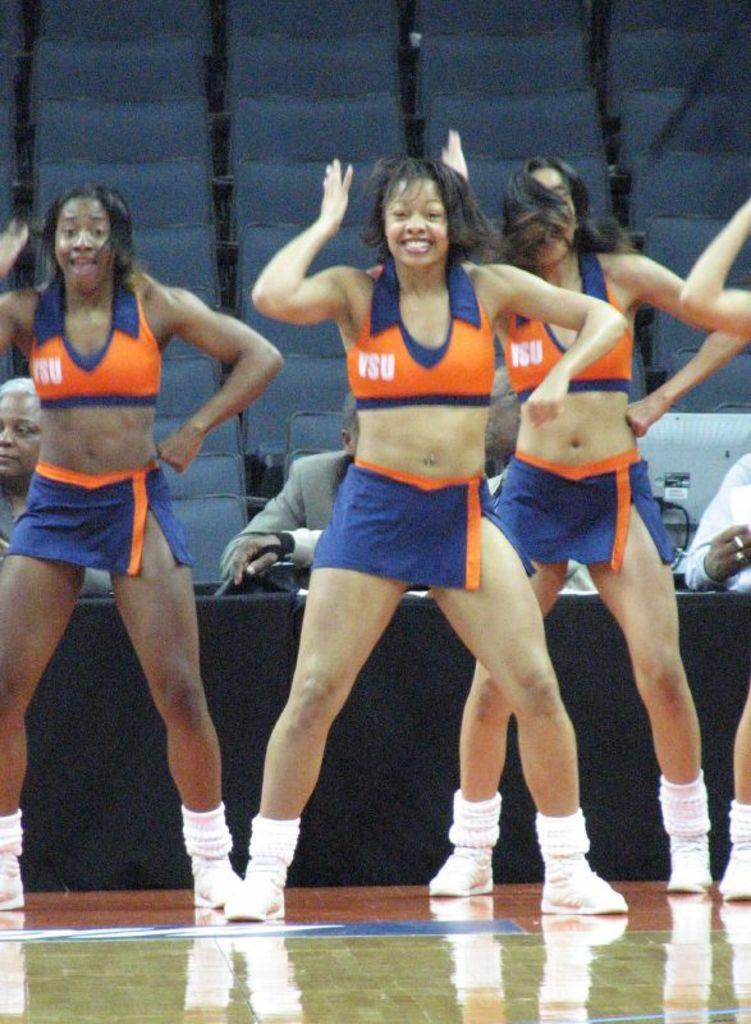<image>
Render a clear and concise summary of the photo. Girls in uniforms with VSU on their tops perform in a gym. 